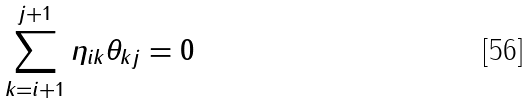Convert formula to latex. <formula><loc_0><loc_0><loc_500><loc_500>\sum _ { k = i + 1 } ^ { j + 1 } \eta _ { i k } \theta _ { k j } = 0</formula> 